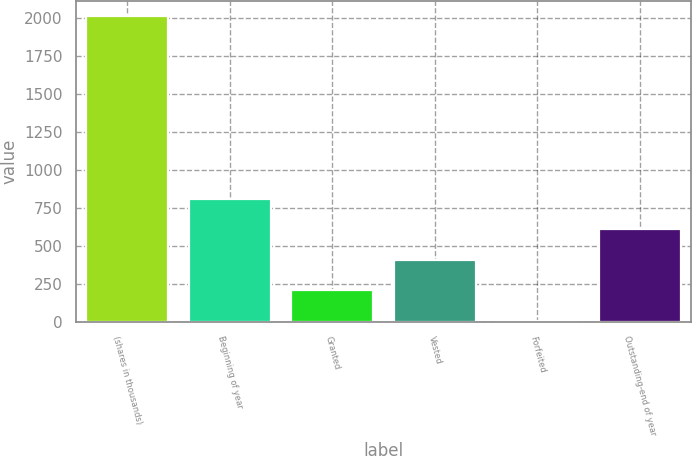<chart> <loc_0><loc_0><loc_500><loc_500><bar_chart><fcel>(shares in thousands)<fcel>Beginning of year<fcel>Granted<fcel>Vested<fcel>Forfeited<fcel>Outstanding-end of year<nl><fcel>2012<fcel>809<fcel>207.5<fcel>408<fcel>7<fcel>608.5<nl></chart> 